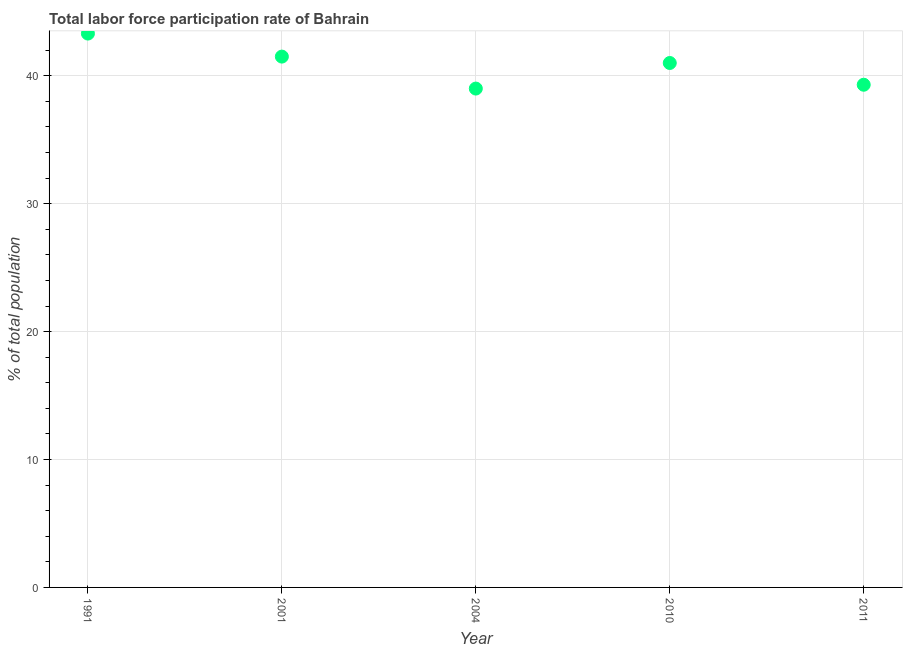What is the total labor force participation rate in 1991?
Make the answer very short. 43.3. Across all years, what is the maximum total labor force participation rate?
Ensure brevity in your answer.  43.3. In which year was the total labor force participation rate maximum?
Keep it short and to the point. 1991. In which year was the total labor force participation rate minimum?
Provide a succinct answer. 2004. What is the sum of the total labor force participation rate?
Your answer should be compact. 204.1. What is the average total labor force participation rate per year?
Provide a short and direct response. 40.82. Do a majority of the years between 1991 and 2011 (inclusive) have total labor force participation rate greater than 12 %?
Provide a short and direct response. Yes. What is the ratio of the total labor force participation rate in 1991 to that in 2001?
Offer a very short reply. 1.04. What is the difference between the highest and the second highest total labor force participation rate?
Provide a succinct answer. 1.8. Is the sum of the total labor force participation rate in 2001 and 2011 greater than the maximum total labor force participation rate across all years?
Your response must be concise. Yes. What is the difference between the highest and the lowest total labor force participation rate?
Give a very brief answer. 4.3. In how many years, is the total labor force participation rate greater than the average total labor force participation rate taken over all years?
Ensure brevity in your answer.  3. Does the total labor force participation rate monotonically increase over the years?
Ensure brevity in your answer.  No. How many years are there in the graph?
Your response must be concise. 5. Are the values on the major ticks of Y-axis written in scientific E-notation?
Offer a very short reply. No. Does the graph contain grids?
Your answer should be very brief. Yes. What is the title of the graph?
Keep it short and to the point. Total labor force participation rate of Bahrain. What is the label or title of the Y-axis?
Give a very brief answer. % of total population. What is the % of total population in 1991?
Your response must be concise. 43.3. What is the % of total population in 2001?
Your answer should be very brief. 41.5. What is the % of total population in 2004?
Your response must be concise. 39. What is the % of total population in 2010?
Your answer should be compact. 41. What is the % of total population in 2011?
Offer a terse response. 39.3. What is the difference between the % of total population in 1991 and 2001?
Your answer should be very brief. 1.8. What is the difference between the % of total population in 2001 and 2010?
Ensure brevity in your answer.  0.5. What is the difference between the % of total population in 2001 and 2011?
Your answer should be very brief. 2.2. What is the difference between the % of total population in 2004 and 2010?
Offer a terse response. -2. What is the ratio of the % of total population in 1991 to that in 2001?
Make the answer very short. 1.04. What is the ratio of the % of total population in 1991 to that in 2004?
Ensure brevity in your answer.  1.11. What is the ratio of the % of total population in 1991 to that in 2010?
Keep it short and to the point. 1.06. What is the ratio of the % of total population in 1991 to that in 2011?
Ensure brevity in your answer.  1.1. What is the ratio of the % of total population in 2001 to that in 2004?
Offer a very short reply. 1.06. What is the ratio of the % of total population in 2001 to that in 2011?
Make the answer very short. 1.06. What is the ratio of the % of total population in 2004 to that in 2010?
Provide a succinct answer. 0.95. What is the ratio of the % of total population in 2004 to that in 2011?
Ensure brevity in your answer.  0.99. What is the ratio of the % of total population in 2010 to that in 2011?
Your answer should be very brief. 1.04. 